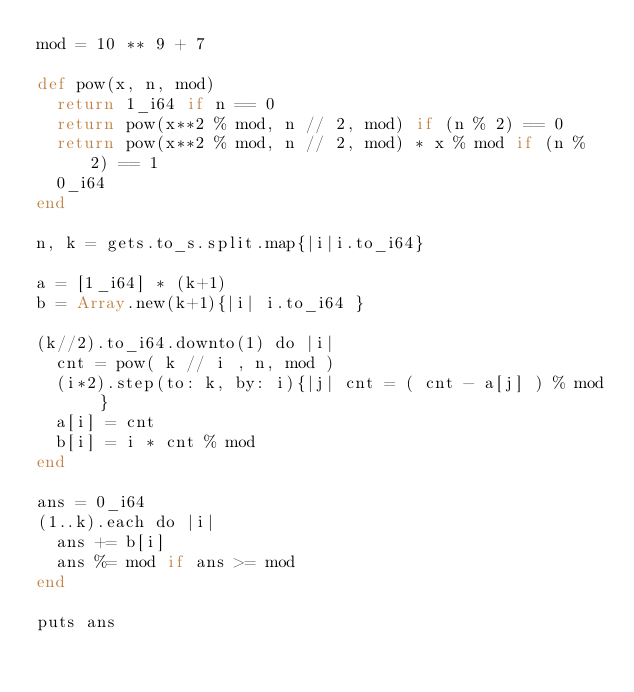Convert code to text. <code><loc_0><loc_0><loc_500><loc_500><_Crystal_>mod = 10 ** 9 + 7

def pow(x, n, mod)
  return 1_i64 if n == 0
  return pow(x**2 % mod, n // 2, mod) if (n % 2) == 0
  return pow(x**2 % mod, n // 2, mod) * x % mod if (n % 2) == 1
  0_i64
end

n, k = gets.to_s.split.map{|i|i.to_i64}

a = [1_i64] * (k+1)
b = Array.new(k+1){|i| i.to_i64 }

(k//2).to_i64.downto(1) do |i|
  cnt = pow( k // i , n, mod )
  (i*2).step(to: k, by: i){|j| cnt = ( cnt - a[j] ) % mod }
  a[i] = cnt
  b[i] = i * cnt % mod
end

ans = 0_i64
(1..k).each do |i|
  ans += b[i]
  ans %= mod if ans >= mod
end

puts ans</code> 